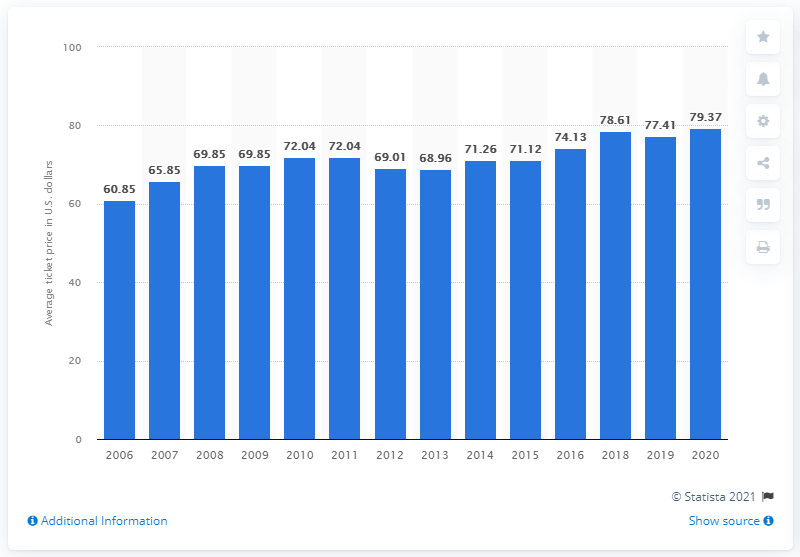Mention a couple of crucial points in this snapshot. The average ticket price for Cincinnati Bengals games in 2020 was 79.37 dollars. 